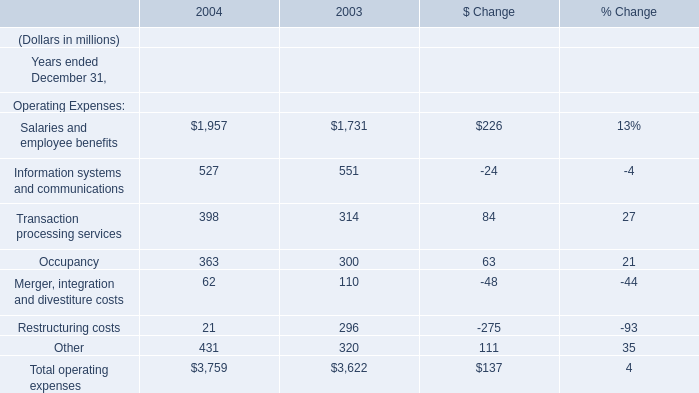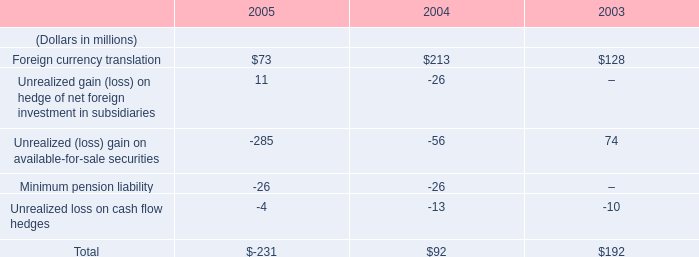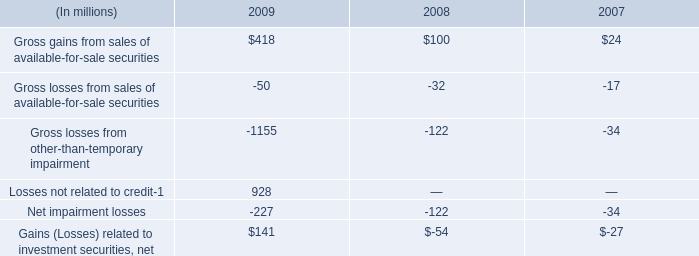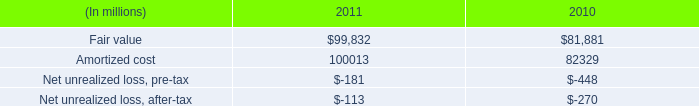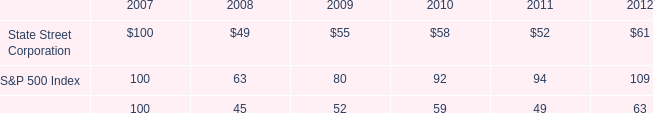what was the percent change in gross gains from sales of available-for-sale securities between 2008 and 2009? 
Computations: ((418 - 100) / 100)
Answer: 3.18. 